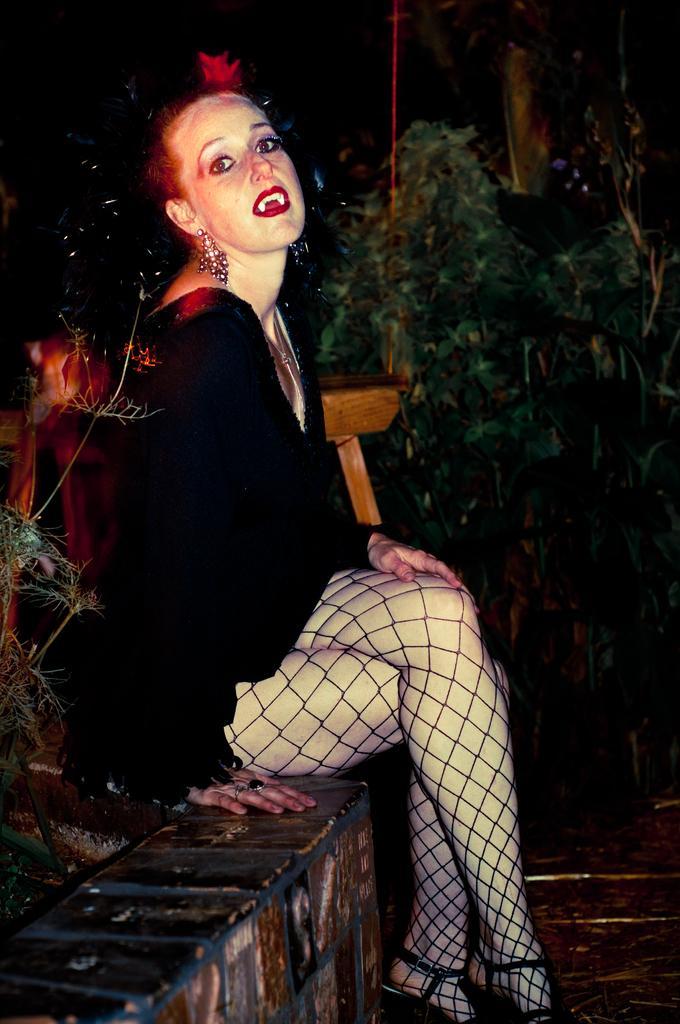Can you describe this image briefly? In this image we can see a woman sitting on the pavement. In the background we can see trees. 